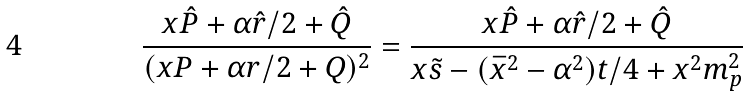Convert formula to latex. <formula><loc_0><loc_0><loc_500><loc_500>\frac { x \hat { P } + \alpha \hat { r } / 2 + \hat { Q } } { ( x P + \alpha r / 2 + Q ) ^ { 2 } } = \frac { x \hat { P } + \alpha \hat { r } / 2 + \hat { Q } } { x \tilde { s } - ( \bar { x } ^ { 2 } - \alpha ^ { 2 } ) t / 4 + x ^ { 2 } m _ { p } ^ { 2 } }</formula> 